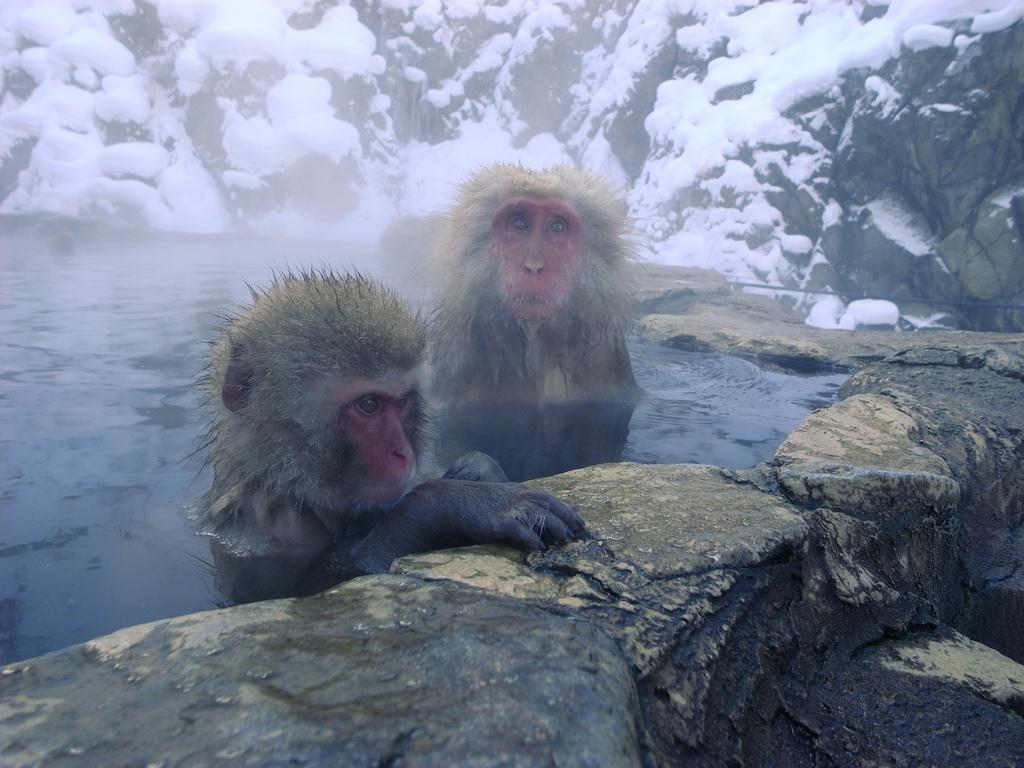How many monkeys are in the image? There are two monkeys in the image. Where are the monkeys located in the image? The monkeys are in the water. What are the monkeys holding onto in the image? The monkeys have their hands on a stone. What can be seen in the background of the image? There are stones visible in the background of the image. What type of flowers can be seen growing near the monkeys in the image? There are no flowers visible in the image; it features two monkeys in the water holding onto a stone. 